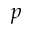<formula> <loc_0><loc_0><loc_500><loc_500>p</formula> 